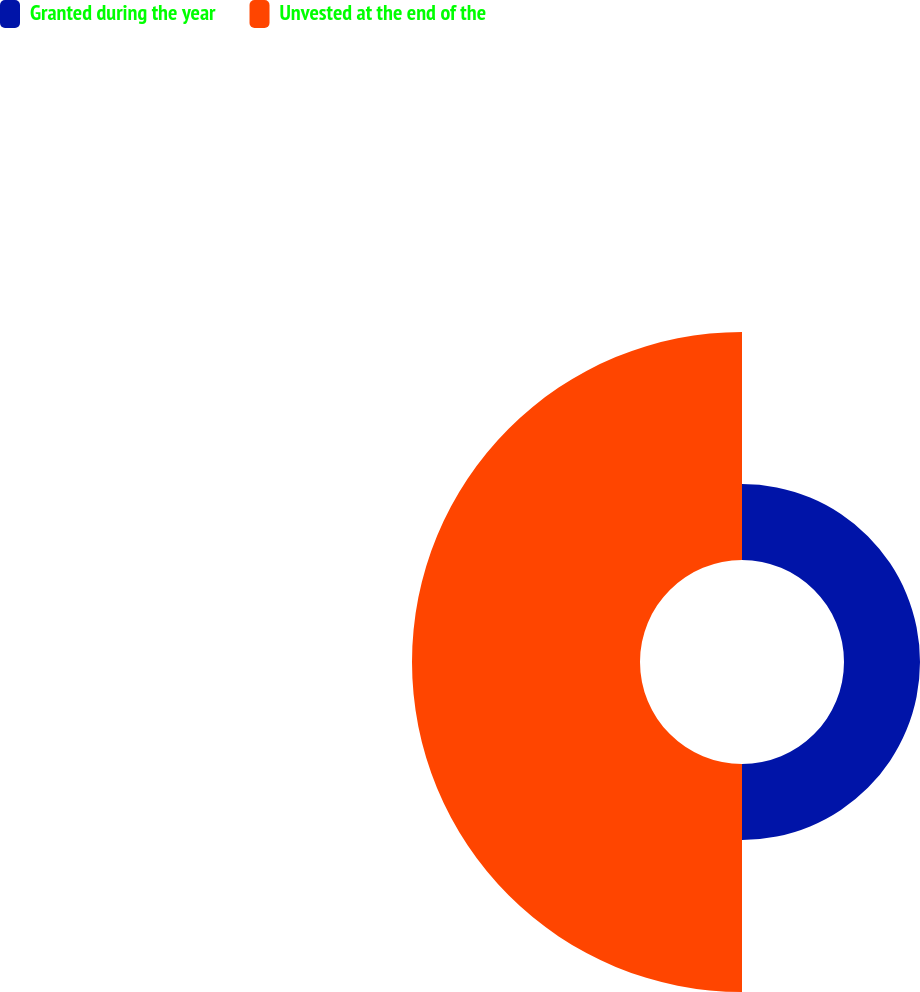<chart> <loc_0><loc_0><loc_500><loc_500><pie_chart><fcel>Granted during the year<fcel>Unvested at the end of the<nl><fcel>25.0%<fcel>75.0%<nl></chart> 